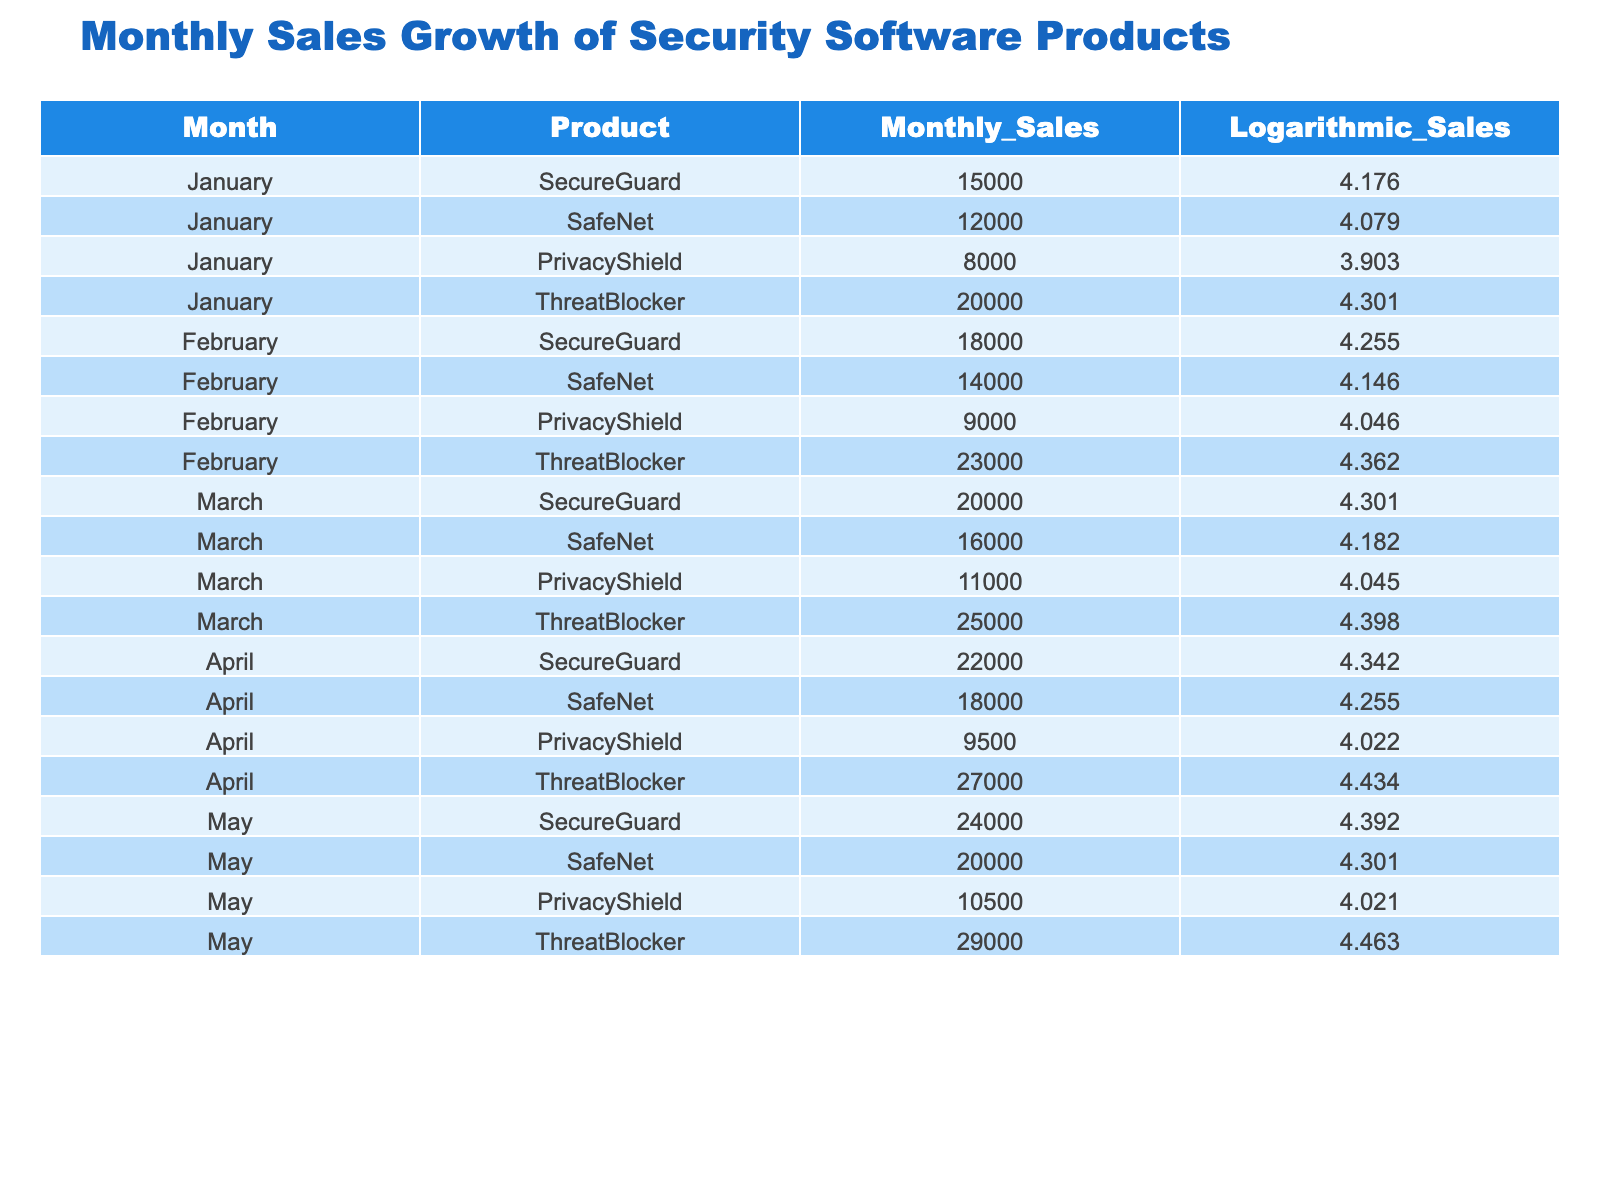What was the highest monthly sales figure recorded for ThreatBlocker? In the table, the Monthly_Sales for ThreatBlocker for each month is: 20000 (January), 23000 (February), 25000 (March), 27000 (April), and 29000 (May). The highest value among these is 29000.
Answer: 29000 What were the logarithmic sales values for SecureGuard across the months? The Logarithmic_Sales values for SecureGuard are: 4.176 (January), 4.255 (February), 4.301 (March), 4.342 (April), and 4.392 (May).
Answer: 4.176, 4.255, 4.301, 4.342, 4.392 Did SafeNet’s sales increase every month from January to May? The Monthly_Sales for SafeNet are 12000 (January), 14000 (February), 16000 (March), 18000 (April), and 20000 (May). Since the sales figures show a consistent increase, we can say that SafeNet's sales increased every month from January to May.
Answer: Yes What was the average monthly sales for PrivacyShield from January to May? The Monthly_Sales figures for PrivacyShield are: 8000 (January), 9000 (February), 11000 (March), 9500 (April), and 10500 (May). Adding these gives a total of 8000 + 9000 + 11000 + 9500 + 10500 = 50500. Dividing this by 5 (the number of months) gives an average of 10100.
Answer: 10100 In which month did SecureGuard show the highest logarithmic value? The Logarithmic_Sales for SecureGuard are 4.176 (January), 4.255 (February), 4.301 (March), 4.342 (April), and 4.392 (May). The highest value is 4.392 in May.
Answer: May What was the difference in monthly sales between the highest and lowest figures for PrivacyShield? The highest monthly sales figure for PrivacyShield is 11000 (March) and the lowest is 8000 (January). The difference is calculated as 11000 - 8000 = 3000.
Answer: 3000 Which product had the highest logarithmic sales value in February? The logarithmic values for February are: SecureGuard (4.255), SafeNet (4.146), PrivacyShield (4.046), and ThreatBlocker (4.362). The highest logarithmic sales value is for ThreatBlocker at 4.362.
Answer: ThreatBlocker What is the overall trend for SecureGuard's sales from January to May? Looking at the Monthly_Sales values for SecureGuard: 15000 (January), 18000 (February), 20000 (March), 22000 (April), and 24000 (May), we observe a consistent increase each month. So, the overall trend is an upward trend in sales.
Answer: Upward trend What is the cumulative total of monthly sales for SafeNet from January to May? The Monthly_Sales for SafeNet are: 12000 (January), 14000 (February), 16000 (March), 18000 (April), and 20000 (May). The cumulative total is 12000 + 14000 + 16000 + 18000 + 20000 = 100000.
Answer: 100000 